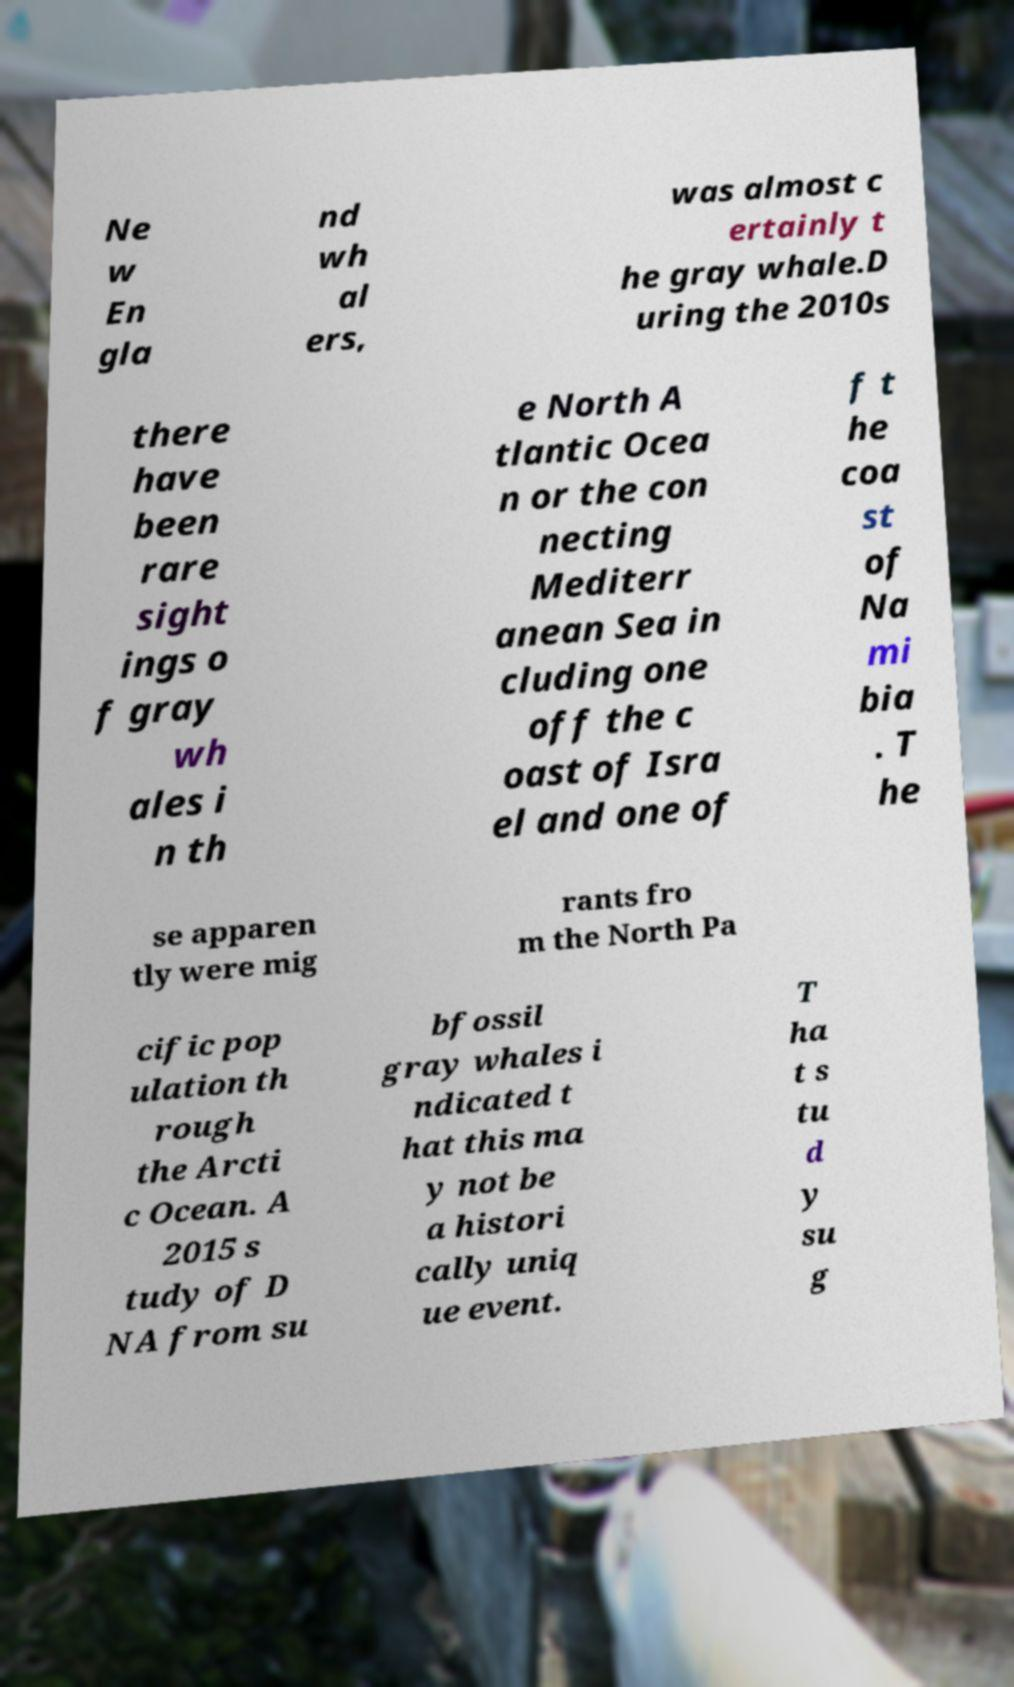There's text embedded in this image that I need extracted. Can you transcribe it verbatim? Ne w En gla nd wh al ers, was almost c ertainly t he gray whale.D uring the 2010s there have been rare sight ings o f gray wh ales i n th e North A tlantic Ocea n or the con necting Mediterr anean Sea in cluding one off the c oast of Isra el and one of f t he coa st of Na mi bia . T he se apparen tly were mig rants fro m the North Pa cific pop ulation th rough the Arcti c Ocean. A 2015 s tudy of D NA from su bfossil gray whales i ndicated t hat this ma y not be a histori cally uniq ue event. T ha t s tu d y su g 